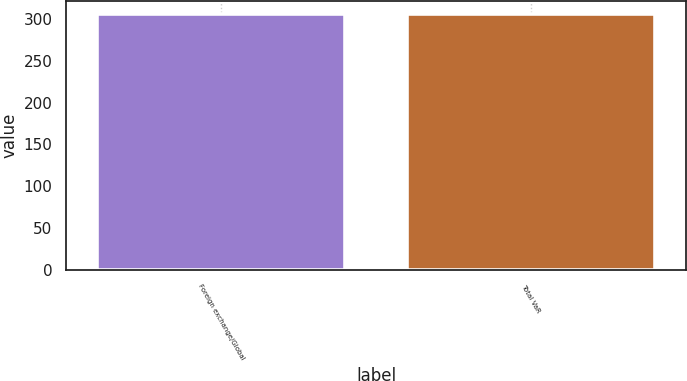Convert chart. <chart><loc_0><loc_0><loc_500><loc_500><bar_chart><fcel>Foreign exchange/Global<fcel>Total VaR<nl><fcel>306<fcel>306.1<nl></chart> 